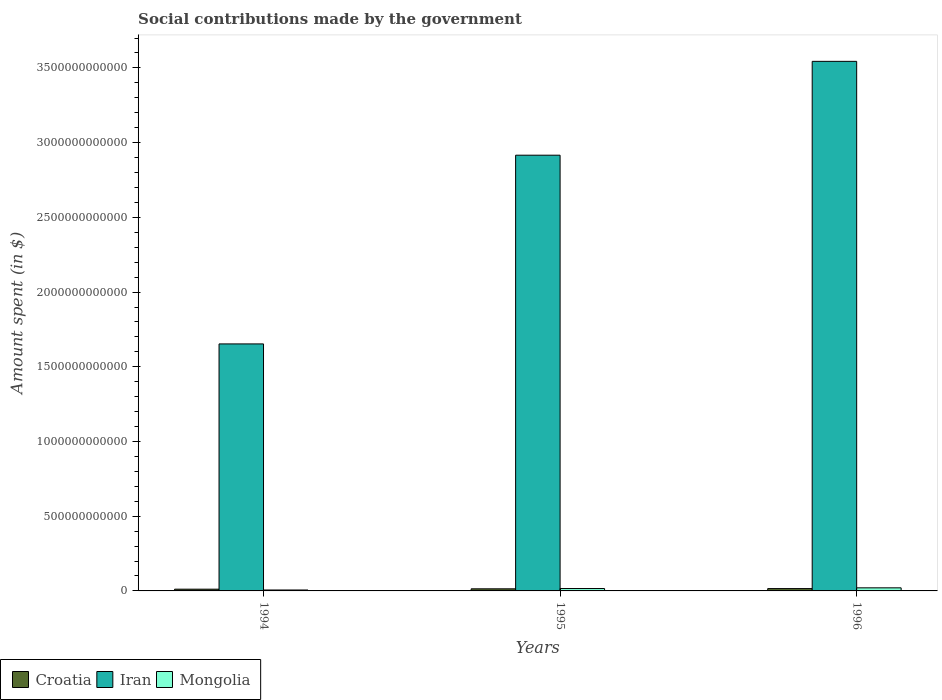How many different coloured bars are there?
Make the answer very short. 3. How many bars are there on the 1st tick from the left?
Your answer should be very brief. 3. In how many cases, is the number of bars for a given year not equal to the number of legend labels?
Provide a succinct answer. 0. What is the amount spent on social contributions in Croatia in 1995?
Your response must be concise. 1.40e+1. Across all years, what is the maximum amount spent on social contributions in Mongolia?
Provide a short and direct response. 2.07e+1. Across all years, what is the minimum amount spent on social contributions in Croatia?
Give a very brief answer. 1.16e+1. In which year was the amount spent on social contributions in Mongolia maximum?
Offer a terse response. 1996. In which year was the amount spent on social contributions in Croatia minimum?
Keep it short and to the point. 1994. What is the total amount spent on social contributions in Croatia in the graph?
Offer a terse response. 4.13e+1. What is the difference between the amount spent on social contributions in Mongolia in 1994 and that in 1996?
Offer a terse response. -1.44e+1. What is the difference between the amount spent on social contributions in Croatia in 1996 and the amount spent on social contributions in Iran in 1994?
Give a very brief answer. -1.64e+12. What is the average amount spent on social contributions in Croatia per year?
Keep it short and to the point. 1.38e+1. In the year 1996, what is the difference between the amount spent on social contributions in Croatia and amount spent on social contributions in Iran?
Provide a succinct answer. -3.53e+12. What is the ratio of the amount spent on social contributions in Iran in 1994 to that in 1996?
Offer a terse response. 0.47. Is the difference between the amount spent on social contributions in Croatia in 1994 and 1995 greater than the difference between the amount spent on social contributions in Iran in 1994 and 1995?
Make the answer very short. Yes. What is the difference between the highest and the second highest amount spent on social contributions in Mongolia?
Keep it short and to the point. 4.62e+09. What is the difference between the highest and the lowest amount spent on social contributions in Iran?
Provide a short and direct response. 1.89e+12. What does the 3rd bar from the left in 1994 represents?
Your answer should be compact. Mongolia. What does the 1st bar from the right in 1995 represents?
Provide a short and direct response. Mongolia. How many bars are there?
Your response must be concise. 9. Are all the bars in the graph horizontal?
Provide a succinct answer. No. How many years are there in the graph?
Provide a succinct answer. 3. What is the difference between two consecutive major ticks on the Y-axis?
Your answer should be compact. 5.00e+11. Where does the legend appear in the graph?
Offer a very short reply. Bottom left. How many legend labels are there?
Provide a short and direct response. 3. What is the title of the graph?
Give a very brief answer. Social contributions made by the government. Does "Europe(all income levels)" appear as one of the legend labels in the graph?
Your response must be concise. No. What is the label or title of the Y-axis?
Your answer should be very brief. Amount spent (in $). What is the Amount spent (in $) of Croatia in 1994?
Provide a succinct answer. 1.16e+1. What is the Amount spent (in $) of Iran in 1994?
Give a very brief answer. 1.65e+12. What is the Amount spent (in $) of Mongolia in 1994?
Provide a succinct answer. 6.21e+09. What is the Amount spent (in $) in Croatia in 1995?
Offer a very short reply. 1.40e+1. What is the Amount spent (in $) in Iran in 1995?
Make the answer very short. 2.92e+12. What is the Amount spent (in $) of Mongolia in 1995?
Make the answer very short. 1.60e+1. What is the Amount spent (in $) of Croatia in 1996?
Offer a terse response. 1.57e+1. What is the Amount spent (in $) in Iran in 1996?
Ensure brevity in your answer.  3.54e+12. What is the Amount spent (in $) of Mongolia in 1996?
Provide a succinct answer. 2.07e+1. Across all years, what is the maximum Amount spent (in $) in Croatia?
Keep it short and to the point. 1.57e+1. Across all years, what is the maximum Amount spent (in $) of Iran?
Offer a very short reply. 3.54e+12. Across all years, what is the maximum Amount spent (in $) of Mongolia?
Make the answer very short. 2.07e+1. Across all years, what is the minimum Amount spent (in $) in Croatia?
Your answer should be very brief. 1.16e+1. Across all years, what is the minimum Amount spent (in $) in Iran?
Offer a very short reply. 1.65e+12. Across all years, what is the minimum Amount spent (in $) of Mongolia?
Keep it short and to the point. 6.21e+09. What is the total Amount spent (in $) in Croatia in the graph?
Offer a terse response. 4.13e+1. What is the total Amount spent (in $) in Iran in the graph?
Your answer should be very brief. 8.11e+12. What is the total Amount spent (in $) in Mongolia in the graph?
Your answer should be very brief. 4.29e+1. What is the difference between the Amount spent (in $) in Croatia in 1994 and that in 1995?
Keep it short and to the point. -2.42e+09. What is the difference between the Amount spent (in $) of Iran in 1994 and that in 1995?
Provide a short and direct response. -1.26e+12. What is the difference between the Amount spent (in $) of Mongolia in 1994 and that in 1995?
Provide a succinct answer. -9.83e+09. What is the difference between the Amount spent (in $) of Croatia in 1994 and that in 1996?
Offer a very short reply. -4.06e+09. What is the difference between the Amount spent (in $) of Iran in 1994 and that in 1996?
Make the answer very short. -1.89e+12. What is the difference between the Amount spent (in $) of Mongolia in 1994 and that in 1996?
Keep it short and to the point. -1.44e+1. What is the difference between the Amount spent (in $) of Croatia in 1995 and that in 1996?
Provide a succinct answer. -1.64e+09. What is the difference between the Amount spent (in $) of Iran in 1995 and that in 1996?
Make the answer very short. -6.28e+11. What is the difference between the Amount spent (in $) of Mongolia in 1995 and that in 1996?
Your answer should be very brief. -4.62e+09. What is the difference between the Amount spent (in $) in Croatia in 1994 and the Amount spent (in $) in Iran in 1995?
Ensure brevity in your answer.  -2.90e+12. What is the difference between the Amount spent (in $) of Croatia in 1994 and the Amount spent (in $) of Mongolia in 1995?
Your answer should be very brief. -4.43e+09. What is the difference between the Amount spent (in $) in Iran in 1994 and the Amount spent (in $) in Mongolia in 1995?
Your answer should be very brief. 1.64e+12. What is the difference between the Amount spent (in $) in Croatia in 1994 and the Amount spent (in $) in Iran in 1996?
Make the answer very short. -3.53e+12. What is the difference between the Amount spent (in $) of Croatia in 1994 and the Amount spent (in $) of Mongolia in 1996?
Offer a very short reply. -9.05e+09. What is the difference between the Amount spent (in $) of Iran in 1994 and the Amount spent (in $) of Mongolia in 1996?
Provide a short and direct response. 1.63e+12. What is the difference between the Amount spent (in $) of Croatia in 1995 and the Amount spent (in $) of Iran in 1996?
Provide a succinct answer. -3.53e+12. What is the difference between the Amount spent (in $) in Croatia in 1995 and the Amount spent (in $) in Mongolia in 1996?
Make the answer very short. -6.63e+09. What is the difference between the Amount spent (in $) of Iran in 1995 and the Amount spent (in $) of Mongolia in 1996?
Offer a terse response. 2.90e+12. What is the average Amount spent (in $) in Croatia per year?
Your answer should be compact. 1.38e+1. What is the average Amount spent (in $) in Iran per year?
Give a very brief answer. 2.70e+12. What is the average Amount spent (in $) of Mongolia per year?
Make the answer very short. 1.43e+1. In the year 1994, what is the difference between the Amount spent (in $) of Croatia and Amount spent (in $) of Iran?
Your answer should be compact. -1.64e+12. In the year 1994, what is the difference between the Amount spent (in $) of Croatia and Amount spent (in $) of Mongolia?
Your answer should be very brief. 5.39e+09. In the year 1994, what is the difference between the Amount spent (in $) in Iran and Amount spent (in $) in Mongolia?
Ensure brevity in your answer.  1.65e+12. In the year 1995, what is the difference between the Amount spent (in $) in Croatia and Amount spent (in $) in Iran?
Provide a short and direct response. -2.90e+12. In the year 1995, what is the difference between the Amount spent (in $) in Croatia and Amount spent (in $) in Mongolia?
Make the answer very short. -2.01e+09. In the year 1995, what is the difference between the Amount spent (in $) of Iran and Amount spent (in $) of Mongolia?
Your answer should be compact. 2.90e+12. In the year 1996, what is the difference between the Amount spent (in $) in Croatia and Amount spent (in $) in Iran?
Make the answer very short. -3.53e+12. In the year 1996, what is the difference between the Amount spent (in $) of Croatia and Amount spent (in $) of Mongolia?
Keep it short and to the point. -5.00e+09. In the year 1996, what is the difference between the Amount spent (in $) in Iran and Amount spent (in $) in Mongolia?
Provide a succinct answer. 3.52e+12. What is the ratio of the Amount spent (in $) of Croatia in 1994 to that in 1995?
Give a very brief answer. 0.83. What is the ratio of the Amount spent (in $) of Iran in 1994 to that in 1995?
Make the answer very short. 0.57. What is the ratio of the Amount spent (in $) of Mongolia in 1994 to that in 1995?
Keep it short and to the point. 0.39. What is the ratio of the Amount spent (in $) in Croatia in 1994 to that in 1996?
Your answer should be very brief. 0.74. What is the ratio of the Amount spent (in $) of Iran in 1994 to that in 1996?
Make the answer very short. 0.47. What is the ratio of the Amount spent (in $) in Mongolia in 1994 to that in 1996?
Keep it short and to the point. 0.3. What is the ratio of the Amount spent (in $) of Croatia in 1995 to that in 1996?
Provide a succinct answer. 0.9. What is the ratio of the Amount spent (in $) in Iran in 1995 to that in 1996?
Your answer should be compact. 0.82. What is the ratio of the Amount spent (in $) of Mongolia in 1995 to that in 1996?
Keep it short and to the point. 0.78. What is the difference between the highest and the second highest Amount spent (in $) of Croatia?
Your response must be concise. 1.64e+09. What is the difference between the highest and the second highest Amount spent (in $) in Iran?
Give a very brief answer. 6.28e+11. What is the difference between the highest and the second highest Amount spent (in $) of Mongolia?
Make the answer very short. 4.62e+09. What is the difference between the highest and the lowest Amount spent (in $) in Croatia?
Provide a succinct answer. 4.06e+09. What is the difference between the highest and the lowest Amount spent (in $) in Iran?
Provide a succinct answer. 1.89e+12. What is the difference between the highest and the lowest Amount spent (in $) in Mongolia?
Provide a short and direct response. 1.44e+1. 